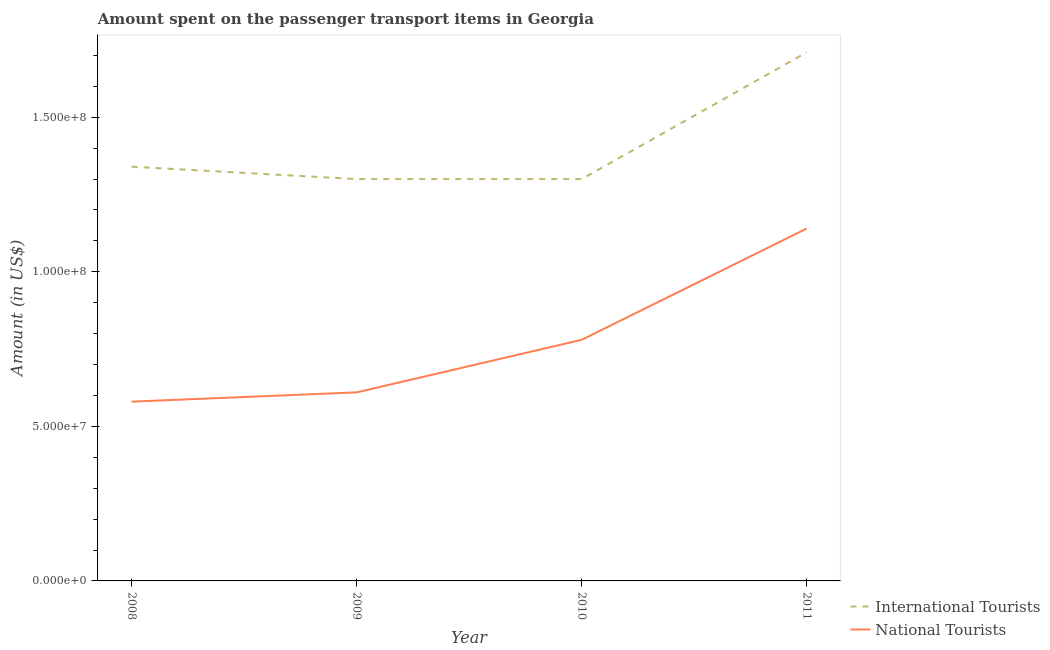How many different coloured lines are there?
Provide a succinct answer. 2. Is the number of lines equal to the number of legend labels?
Your response must be concise. Yes. What is the amount spent on transport items of national tourists in 2010?
Give a very brief answer. 7.80e+07. Across all years, what is the maximum amount spent on transport items of national tourists?
Keep it short and to the point. 1.14e+08. Across all years, what is the minimum amount spent on transport items of international tourists?
Offer a terse response. 1.30e+08. In which year was the amount spent on transport items of national tourists maximum?
Make the answer very short. 2011. What is the total amount spent on transport items of international tourists in the graph?
Make the answer very short. 5.65e+08. What is the difference between the amount spent on transport items of national tourists in 2010 and that in 2011?
Your response must be concise. -3.60e+07. What is the difference between the amount spent on transport items of national tourists in 2010 and the amount spent on transport items of international tourists in 2008?
Ensure brevity in your answer.  -5.60e+07. What is the average amount spent on transport items of national tourists per year?
Ensure brevity in your answer.  7.78e+07. In the year 2009, what is the difference between the amount spent on transport items of international tourists and amount spent on transport items of national tourists?
Your answer should be very brief. 6.90e+07. In how many years, is the amount spent on transport items of national tourists greater than 40000000 US$?
Your answer should be compact. 4. What is the ratio of the amount spent on transport items of national tourists in 2010 to that in 2011?
Your response must be concise. 0.68. Is the amount spent on transport items of international tourists in 2009 less than that in 2010?
Keep it short and to the point. No. What is the difference between the highest and the second highest amount spent on transport items of national tourists?
Your answer should be compact. 3.60e+07. What is the difference between the highest and the lowest amount spent on transport items of international tourists?
Offer a terse response. 4.10e+07. Does the amount spent on transport items of international tourists monotonically increase over the years?
Ensure brevity in your answer.  No. How many years are there in the graph?
Your answer should be compact. 4. What is the difference between two consecutive major ticks on the Y-axis?
Your answer should be compact. 5.00e+07. Does the graph contain grids?
Ensure brevity in your answer.  No. What is the title of the graph?
Offer a terse response. Amount spent on the passenger transport items in Georgia. What is the label or title of the X-axis?
Your answer should be compact. Year. What is the label or title of the Y-axis?
Provide a succinct answer. Amount (in US$). What is the Amount (in US$) of International Tourists in 2008?
Keep it short and to the point. 1.34e+08. What is the Amount (in US$) of National Tourists in 2008?
Offer a very short reply. 5.80e+07. What is the Amount (in US$) in International Tourists in 2009?
Give a very brief answer. 1.30e+08. What is the Amount (in US$) of National Tourists in 2009?
Make the answer very short. 6.10e+07. What is the Amount (in US$) in International Tourists in 2010?
Offer a very short reply. 1.30e+08. What is the Amount (in US$) in National Tourists in 2010?
Ensure brevity in your answer.  7.80e+07. What is the Amount (in US$) in International Tourists in 2011?
Your answer should be compact. 1.71e+08. What is the Amount (in US$) of National Tourists in 2011?
Provide a short and direct response. 1.14e+08. Across all years, what is the maximum Amount (in US$) of International Tourists?
Ensure brevity in your answer.  1.71e+08. Across all years, what is the maximum Amount (in US$) in National Tourists?
Your answer should be compact. 1.14e+08. Across all years, what is the minimum Amount (in US$) in International Tourists?
Provide a succinct answer. 1.30e+08. Across all years, what is the minimum Amount (in US$) in National Tourists?
Keep it short and to the point. 5.80e+07. What is the total Amount (in US$) of International Tourists in the graph?
Give a very brief answer. 5.65e+08. What is the total Amount (in US$) in National Tourists in the graph?
Your response must be concise. 3.11e+08. What is the difference between the Amount (in US$) in National Tourists in 2008 and that in 2010?
Offer a very short reply. -2.00e+07. What is the difference between the Amount (in US$) of International Tourists in 2008 and that in 2011?
Provide a succinct answer. -3.70e+07. What is the difference between the Amount (in US$) of National Tourists in 2008 and that in 2011?
Give a very brief answer. -5.60e+07. What is the difference between the Amount (in US$) of International Tourists in 2009 and that in 2010?
Provide a succinct answer. 0. What is the difference between the Amount (in US$) in National Tourists in 2009 and that in 2010?
Your response must be concise. -1.70e+07. What is the difference between the Amount (in US$) of International Tourists in 2009 and that in 2011?
Your answer should be very brief. -4.10e+07. What is the difference between the Amount (in US$) in National Tourists in 2009 and that in 2011?
Ensure brevity in your answer.  -5.30e+07. What is the difference between the Amount (in US$) of International Tourists in 2010 and that in 2011?
Offer a terse response. -4.10e+07. What is the difference between the Amount (in US$) in National Tourists in 2010 and that in 2011?
Offer a terse response. -3.60e+07. What is the difference between the Amount (in US$) of International Tourists in 2008 and the Amount (in US$) of National Tourists in 2009?
Ensure brevity in your answer.  7.30e+07. What is the difference between the Amount (in US$) of International Tourists in 2008 and the Amount (in US$) of National Tourists in 2010?
Your response must be concise. 5.60e+07. What is the difference between the Amount (in US$) of International Tourists in 2008 and the Amount (in US$) of National Tourists in 2011?
Offer a terse response. 2.00e+07. What is the difference between the Amount (in US$) of International Tourists in 2009 and the Amount (in US$) of National Tourists in 2010?
Your answer should be very brief. 5.20e+07. What is the difference between the Amount (in US$) in International Tourists in 2009 and the Amount (in US$) in National Tourists in 2011?
Offer a very short reply. 1.60e+07. What is the difference between the Amount (in US$) in International Tourists in 2010 and the Amount (in US$) in National Tourists in 2011?
Your answer should be very brief. 1.60e+07. What is the average Amount (in US$) of International Tourists per year?
Make the answer very short. 1.41e+08. What is the average Amount (in US$) in National Tourists per year?
Offer a terse response. 7.78e+07. In the year 2008, what is the difference between the Amount (in US$) of International Tourists and Amount (in US$) of National Tourists?
Give a very brief answer. 7.60e+07. In the year 2009, what is the difference between the Amount (in US$) of International Tourists and Amount (in US$) of National Tourists?
Your answer should be compact. 6.90e+07. In the year 2010, what is the difference between the Amount (in US$) of International Tourists and Amount (in US$) of National Tourists?
Provide a short and direct response. 5.20e+07. In the year 2011, what is the difference between the Amount (in US$) in International Tourists and Amount (in US$) in National Tourists?
Offer a terse response. 5.70e+07. What is the ratio of the Amount (in US$) in International Tourists in 2008 to that in 2009?
Keep it short and to the point. 1.03. What is the ratio of the Amount (in US$) of National Tourists in 2008 to that in 2009?
Ensure brevity in your answer.  0.95. What is the ratio of the Amount (in US$) in International Tourists in 2008 to that in 2010?
Your answer should be compact. 1.03. What is the ratio of the Amount (in US$) in National Tourists in 2008 to that in 2010?
Offer a terse response. 0.74. What is the ratio of the Amount (in US$) of International Tourists in 2008 to that in 2011?
Provide a short and direct response. 0.78. What is the ratio of the Amount (in US$) of National Tourists in 2008 to that in 2011?
Give a very brief answer. 0.51. What is the ratio of the Amount (in US$) in International Tourists in 2009 to that in 2010?
Give a very brief answer. 1. What is the ratio of the Amount (in US$) in National Tourists in 2009 to that in 2010?
Keep it short and to the point. 0.78. What is the ratio of the Amount (in US$) of International Tourists in 2009 to that in 2011?
Offer a very short reply. 0.76. What is the ratio of the Amount (in US$) in National Tourists in 2009 to that in 2011?
Provide a succinct answer. 0.54. What is the ratio of the Amount (in US$) in International Tourists in 2010 to that in 2011?
Offer a terse response. 0.76. What is the ratio of the Amount (in US$) in National Tourists in 2010 to that in 2011?
Provide a succinct answer. 0.68. What is the difference between the highest and the second highest Amount (in US$) in International Tourists?
Ensure brevity in your answer.  3.70e+07. What is the difference between the highest and the second highest Amount (in US$) in National Tourists?
Make the answer very short. 3.60e+07. What is the difference between the highest and the lowest Amount (in US$) in International Tourists?
Ensure brevity in your answer.  4.10e+07. What is the difference between the highest and the lowest Amount (in US$) in National Tourists?
Make the answer very short. 5.60e+07. 